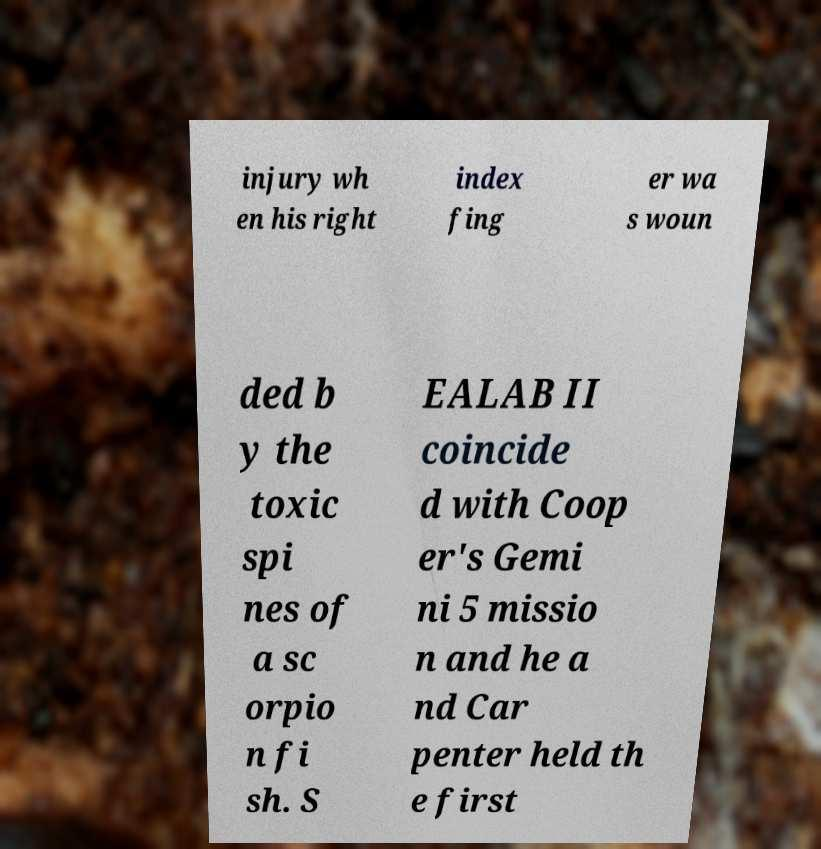What messages or text are displayed in this image? I need them in a readable, typed format. injury wh en his right index fing er wa s woun ded b y the toxic spi nes of a sc orpio n fi sh. S EALAB II coincide d with Coop er's Gemi ni 5 missio n and he a nd Car penter held th e first 